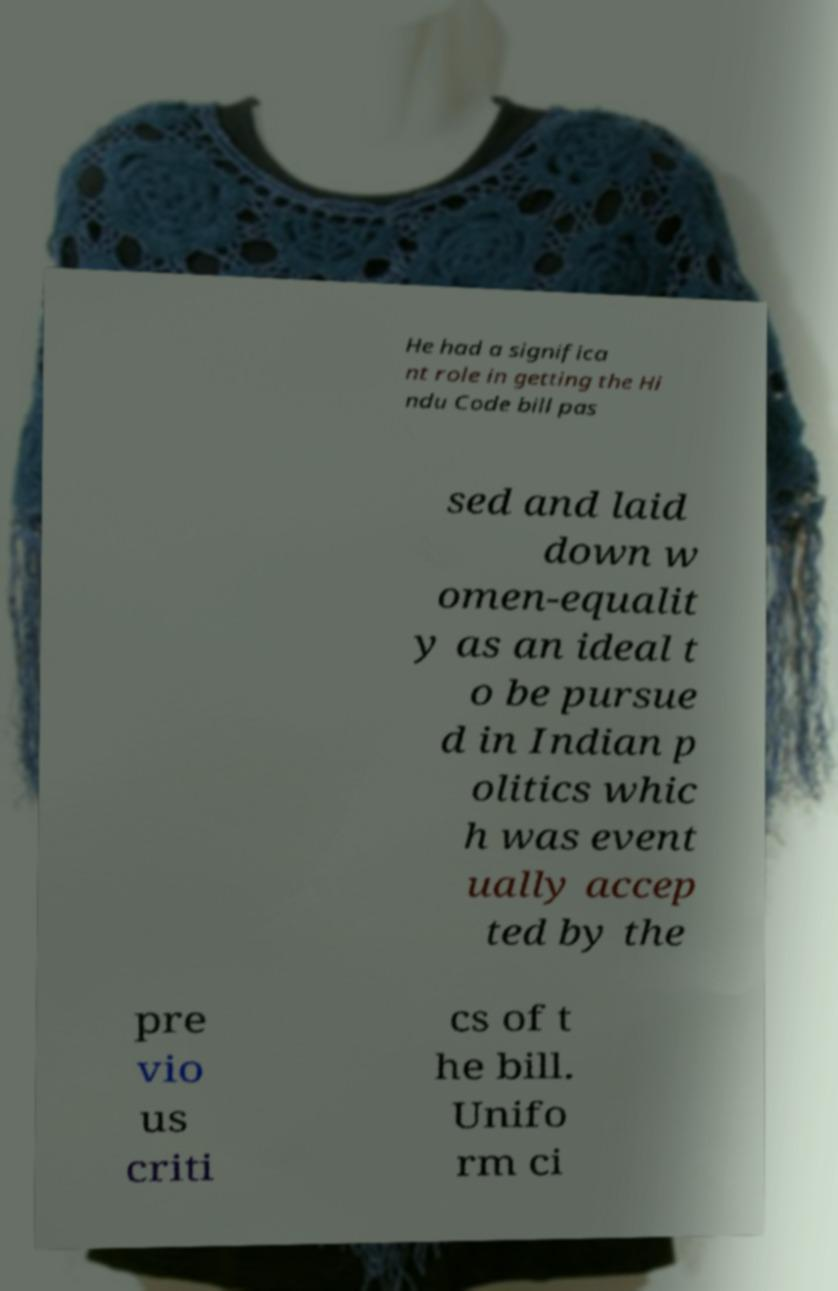Can you accurately transcribe the text from the provided image for me? He had a significa nt role in getting the Hi ndu Code bill pas sed and laid down w omen-equalit y as an ideal t o be pursue d in Indian p olitics whic h was event ually accep ted by the pre vio us criti cs of t he bill. Unifo rm ci 